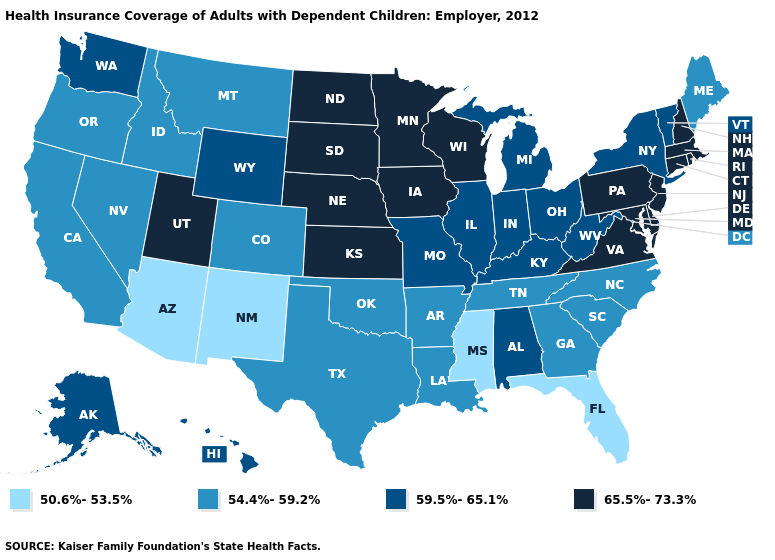What is the highest value in states that border Texas?
Concise answer only. 54.4%-59.2%. What is the lowest value in the South?
Quick response, please. 50.6%-53.5%. What is the highest value in the South ?
Concise answer only. 65.5%-73.3%. Name the states that have a value in the range 54.4%-59.2%?
Give a very brief answer. Arkansas, California, Colorado, Georgia, Idaho, Louisiana, Maine, Montana, Nevada, North Carolina, Oklahoma, Oregon, South Carolina, Tennessee, Texas. Does South Carolina have the same value as Alaska?
Answer briefly. No. Name the states that have a value in the range 54.4%-59.2%?
Keep it brief. Arkansas, California, Colorado, Georgia, Idaho, Louisiana, Maine, Montana, Nevada, North Carolina, Oklahoma, Oregon, South Carolina, Tennessee, Texas. Name the states that have a value in the range 59.5%-65.1%?
Short answer required. Alabama, Alaska, Hawaii, Illinois, Indiana, Kentucky, Michigan, Missouri, New York, Ohio, Vermont, Washington, West Virginia, Wyoming. What is the value of Tennessee?
Keep it brief. 54.4%-59.2%. Which states have the lowest value in the USA?
Be succinct. Arizona, Florida, Mississippi, New Mexico. What is the value of Michigan?
Keep it brief. 59.5%-65.1%. Does Hawaii have a lower value than North Dakota?
Concise answer only. Yes. What is the value of Michigan?
Be succinct. 59.5%-65.1%. How many symbols are there in the legend?
Write a very short answer. 4. What is the lowest value in the West?
Short answer required. 50.6%-53.5%. 